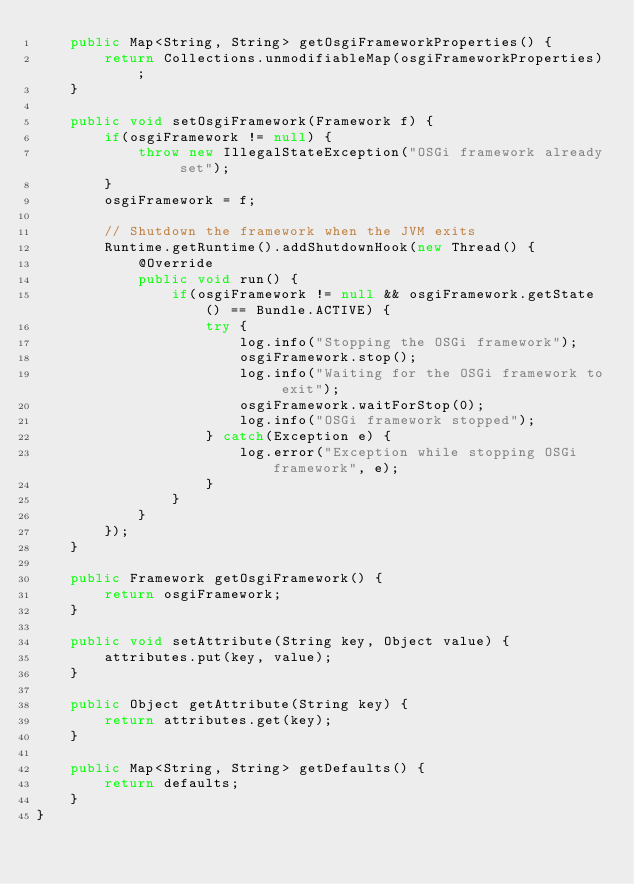<code> <loc_0><loc_0><loc_500><loc_500><_Java_>    public Map<String, String> getOsgiFrameworkProperties() {
        return Collections.unmodifiableMap(osgiFrameworkProperties);
    }
    
    public void setOsgiFramework(Framework f) {
        if(osgiFramework != null) {
            throw new IllegalStateException("OSGi framework already set");
        }
        osgiFramework = f;
        
        // Shutdown the framework when the JVM exits
        Runtime.getRuntime().addShutdownHook(new Thread() {
            @Override
            public void run() {
                if(osgiFramework != null && osgiFramework.getState() == Bundle.ACTIVE) {
                    try {
                        log.info("Stopping the OSGi framework");
                        osgiFramework.stop();
                        log.info("Waiting for the OSGi framework to exit");
                        osgiFramework.waitForStop(0);
                        log.info("OSGi framework stopped");
                    } catch(Exception e) {
                        log.error("Exception while stopping OSGi framework", e);
                    }
                }
            }
        });
    }
    
    public Framework getOsgiFramework() {
        return osgiFramework;
    }
    
    public void setAttribute(String key, Object value) {
        attributes.put(key, value);
    }
    
    public Object getAttribute(String key) {
        return attributes.get(key);
    }
    
    public Map<String, String> getDefaults() {
        return defaults;
    }
}</code> 